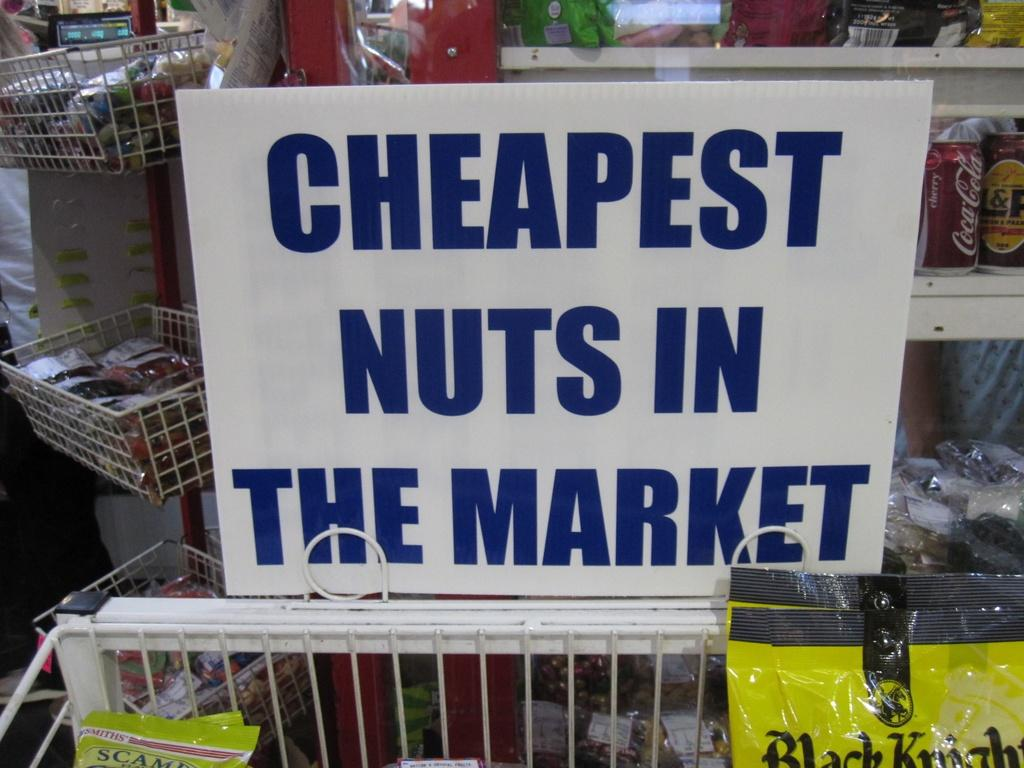What is the main object in the image with text on it? There is a board with text in the image. What type of storage units are visible in the image? There are shelves with items in the image. What other type of containers are present in the image? There are baskets with items in the image. What type of establishment might the image depict? The image appears to depict a store. What type of snake can be seen slithering through the clouds in the image? There are no clouds or snakes present in the image; it depicts a store with a board, shelves, and baskets. 